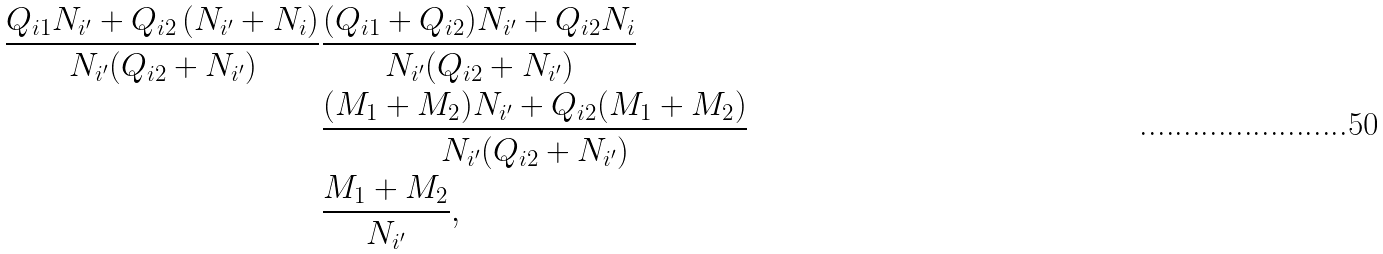<formula> <loc_0><loc_0><loc_500><loc_500>\frac { Q _ { i 1 } N _ { i ^ { \prime } } + Q _ { i 2 } \left ( N _ { i ^ { \prime } } + N _ { i } \right ) } { N _ { i ^ { \prime } } ( Q _ { i 2 } + N _ { i ^ { \prime } } ) } & \frac { ( Q _ { i 1 } + Q _ { i 2 } ) N _ { i ^ { \prime } } + Q _ { i 2 } N _ { i } } { N _ { i ^ { \prime } } ( Q _ { i 2 } + N _ { i ^ { \prime } } ) } \\ & \frac { ( M _ { 1 } + M _ { 2 } ) N _ { i ^ { \prime } } + Q _ { i 2 } ( M _ { 1 } + M _ { 2 } ) } { N _ { i ^ { \prime } } ( Q _ { i 2 } + N _ { i ^ { \prime } } ) } \\ & \frac { M _ { 1 } + M _ { 2 } } { N _ { i ^ { \prime } } } ,</formula> 